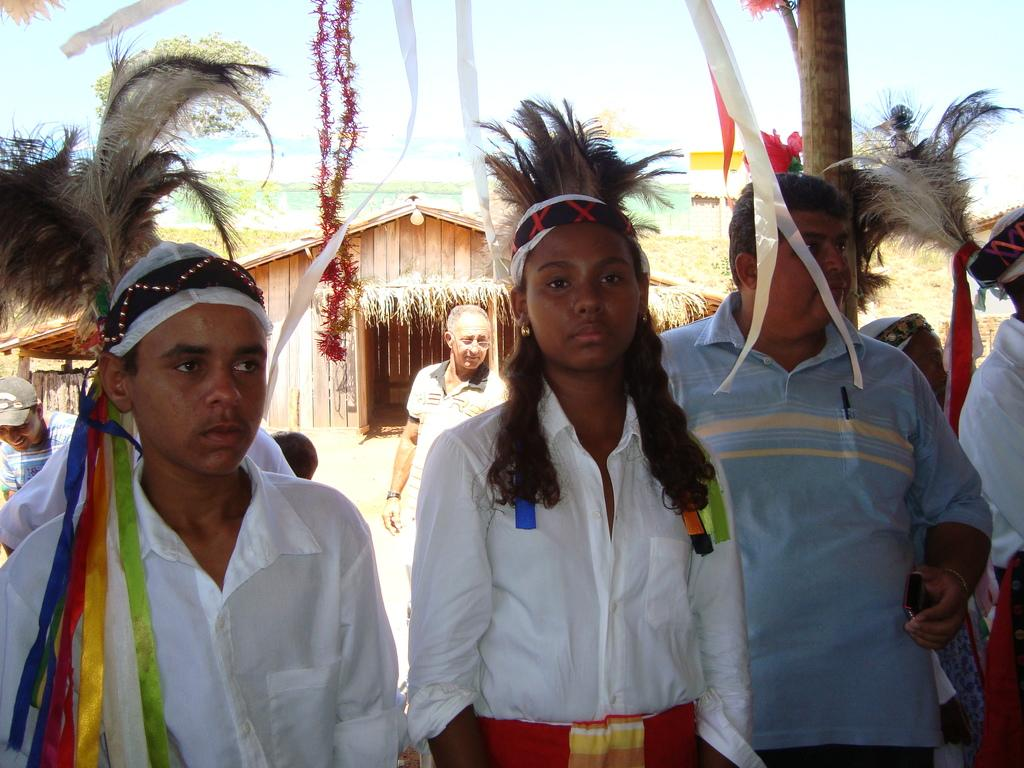How many people are in the image? There are persons in the image, but the exact number is not specified. What can be seen in the background of the image? There is a hut in the background of the image. What type of magic is being performed by the men in the image? There is no mention of magic or men in the image, so it is not possible to answer that question. 